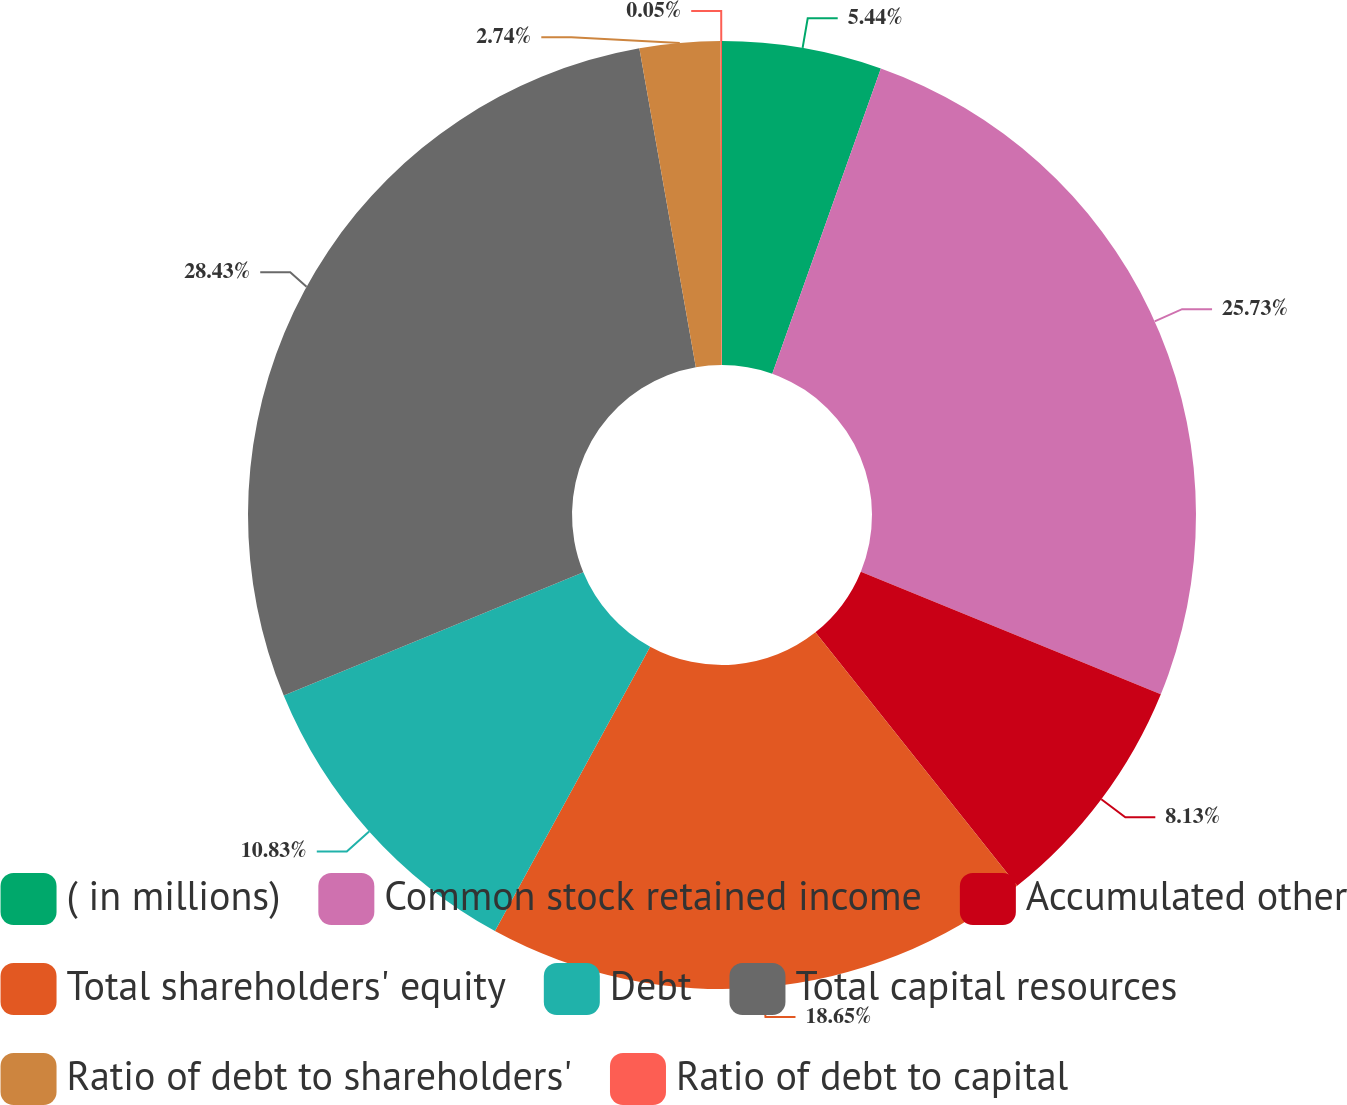<chart> <loc_0><loc_0><loc_500><loc_500><pie_chart><fcel>( in millions)<fcel>Common stock retained income<fcel>Accumulated other<fcel>Total shareholders' equity<fcel>Debt<fcel>Total capital resources<fcel>Ratio of debt to shareholders'<fcel>Ratio of debt to capital<nl><fcel>5.44%<fcel>25.73%<fcel>8.13%<fcel>18.65%<fcel>10.83%<fcel>28.43%<fcel>2.74%<fcel>0.05%<nl></chart> 